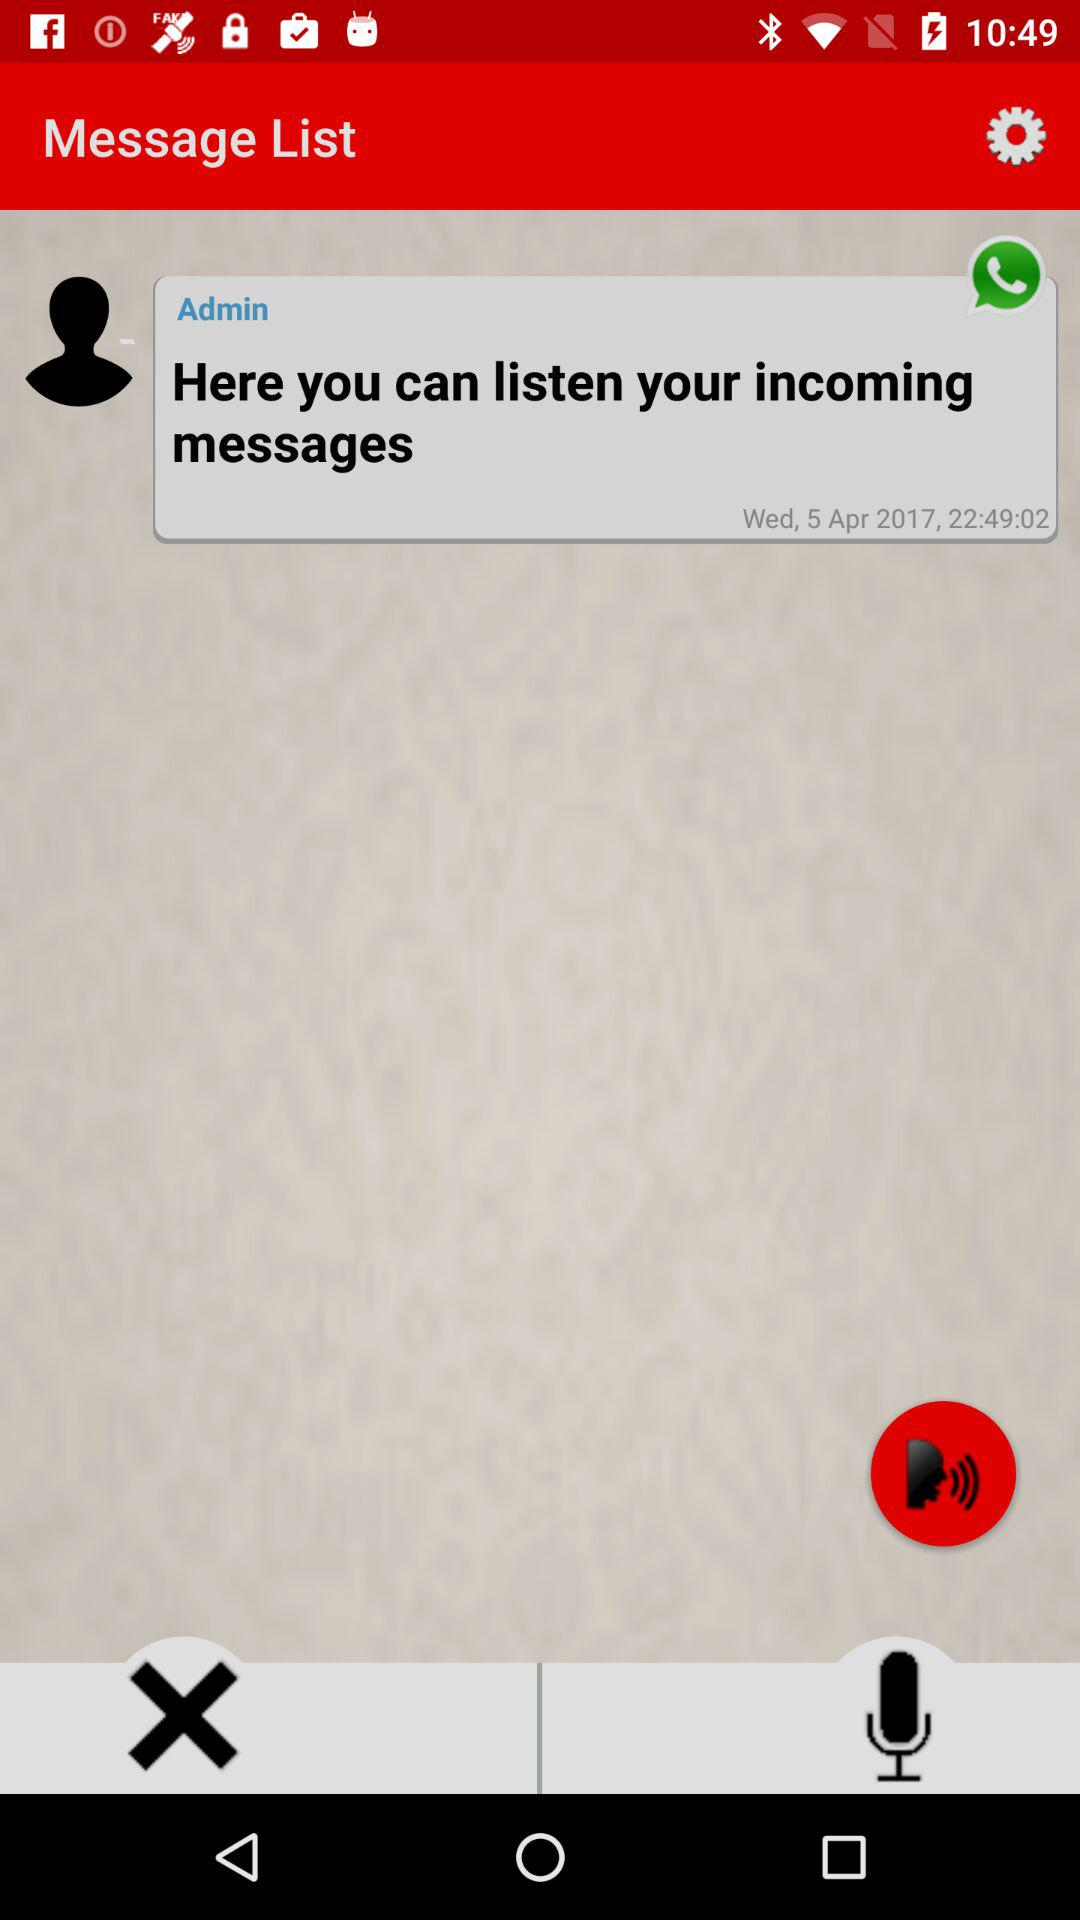What is the date of the message? The date of the message is April 5, 2017. 